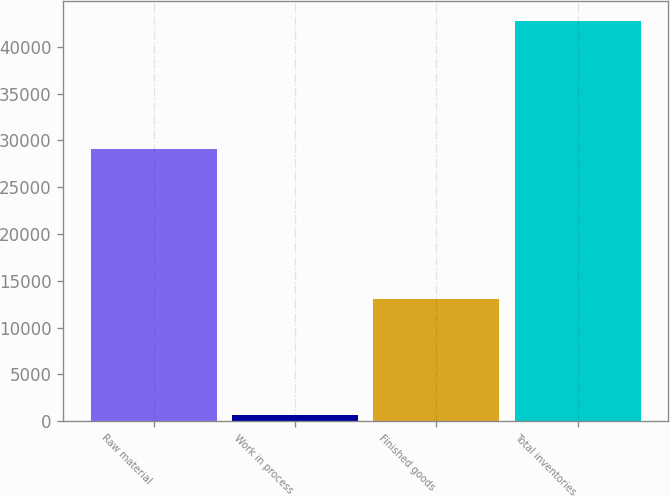<chart> <loc_0><loc_0><loc_500><loc_500><bar_chart><fcel>Raw material<fcel>Work in process<fcel>Finished goods<fcel>Total inventories<nl><fcel>29127<fcel>645<fcel>13009<fcel>42781<nl></chart> 